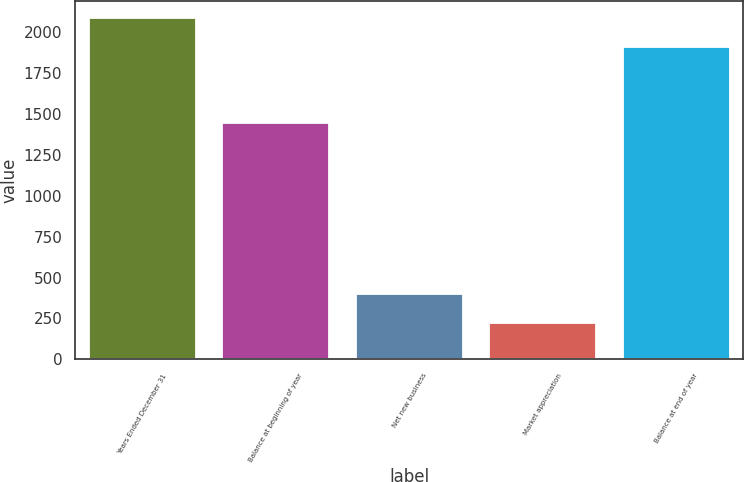Convert chart to OTSL. <chart><loc_0><loc_0><loc_500><loc_500><bar_chart><fcel>Years Ended December 31<fcel>Balance at beginning of year<fcel>Net new business<fcel>Market appreciation<fcel>Balance at end of year<nl><fcel>2090<fcel>1444<fcel>398<fcel>219<fcel>1911<nl></chart> 